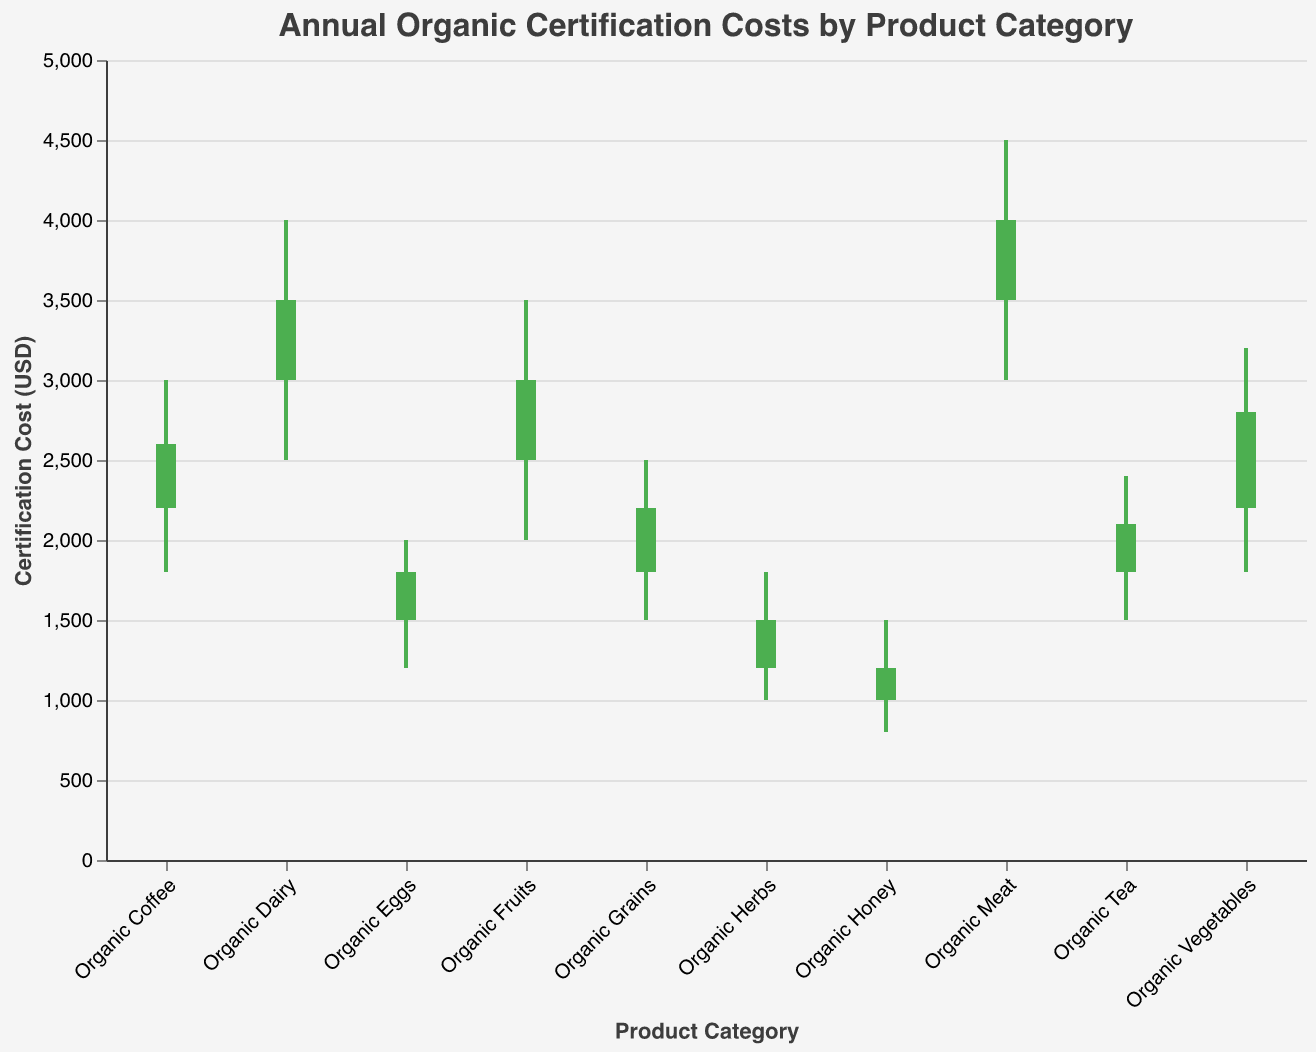What is the title of the chart? The title is displayed at the top of the chart. It reads "Annual Organic Certification Costs by Product Category".
Answer: Annual Organic Certification Costs by Product Category How many product categories are represented in the chart? The chart lists each product category on the x-axis. By counting each category label, we see there are 10 categories.
Answer: 10 Which product category has the highest certification cost at its peak? By comparing the highest points of each product category (High values), Organic Meat has the highest certification cost at 4500 USD.
Answer: Organic Meat Which product category shows the largest difference between its lowest and highest certification cost? Calculate the difference between High and Low for each category and compare. Organic Dairy's difference is 4000 - 2500 = 1500. Organic Meat's difference is 4500 - 3000 = 1500. The largest difference is 1500 USD, found in both Organic Dairy and Organic Meat.
Answer: Organic Dairy and Organic Meat What is the minimum certification cost for Organic Coffee? Look at the Low value for Organic Coffee, which is 1800 USD.
Answer: 1800 USD For which product categories do the certification costs increase from open to close? Categories where the Close value is higher than the Open value have increasing costs. Organic Fruits (3000 > 2500), Organic Vegetables (2800 > 2200), Organic Dairy (3500 > 3000), Organic Meat (4000 > 3500), Organic Coffee (2600 > 2200), and Organic Tea (2100 > 1800) all exhibit this pattern.
Answer: Organic Fruits, Organic Vegetables, Organic Dairy, Organic Meat, Organic Coffee, Organic Tea Which product category has the lowest opening certification cost? Compare the Open values of all categories. Organic Honey has the lowest with 1000 USD.
Answer: Organic Honey What is the average of the closing certification costs for Organic Eggs, Organic Honey, and Organic Herbs? Add the closing costs for these categories: Organic Eggs (1800), Organic Honey (1200), Organic Herbs (1500), then divide by 3. (1800 + 1200 + 1500) / 3 = 1500 USD.
Answer: 1500 USD Which category has the smallest range between its quotation marks low, open, close, and high values? Calculate the range (High - Low) for each category. The smallest range is for Organic Honey, ranging from 800 to 1500 with a difference of 700 USD.
Answer: Organic Honey What color is used to indicate a decrease in certification cost from open to close? Colors in the chart are assigned based on the comparison of Open and Close values. A decrease is indicated by a red color.
Answer: Red 